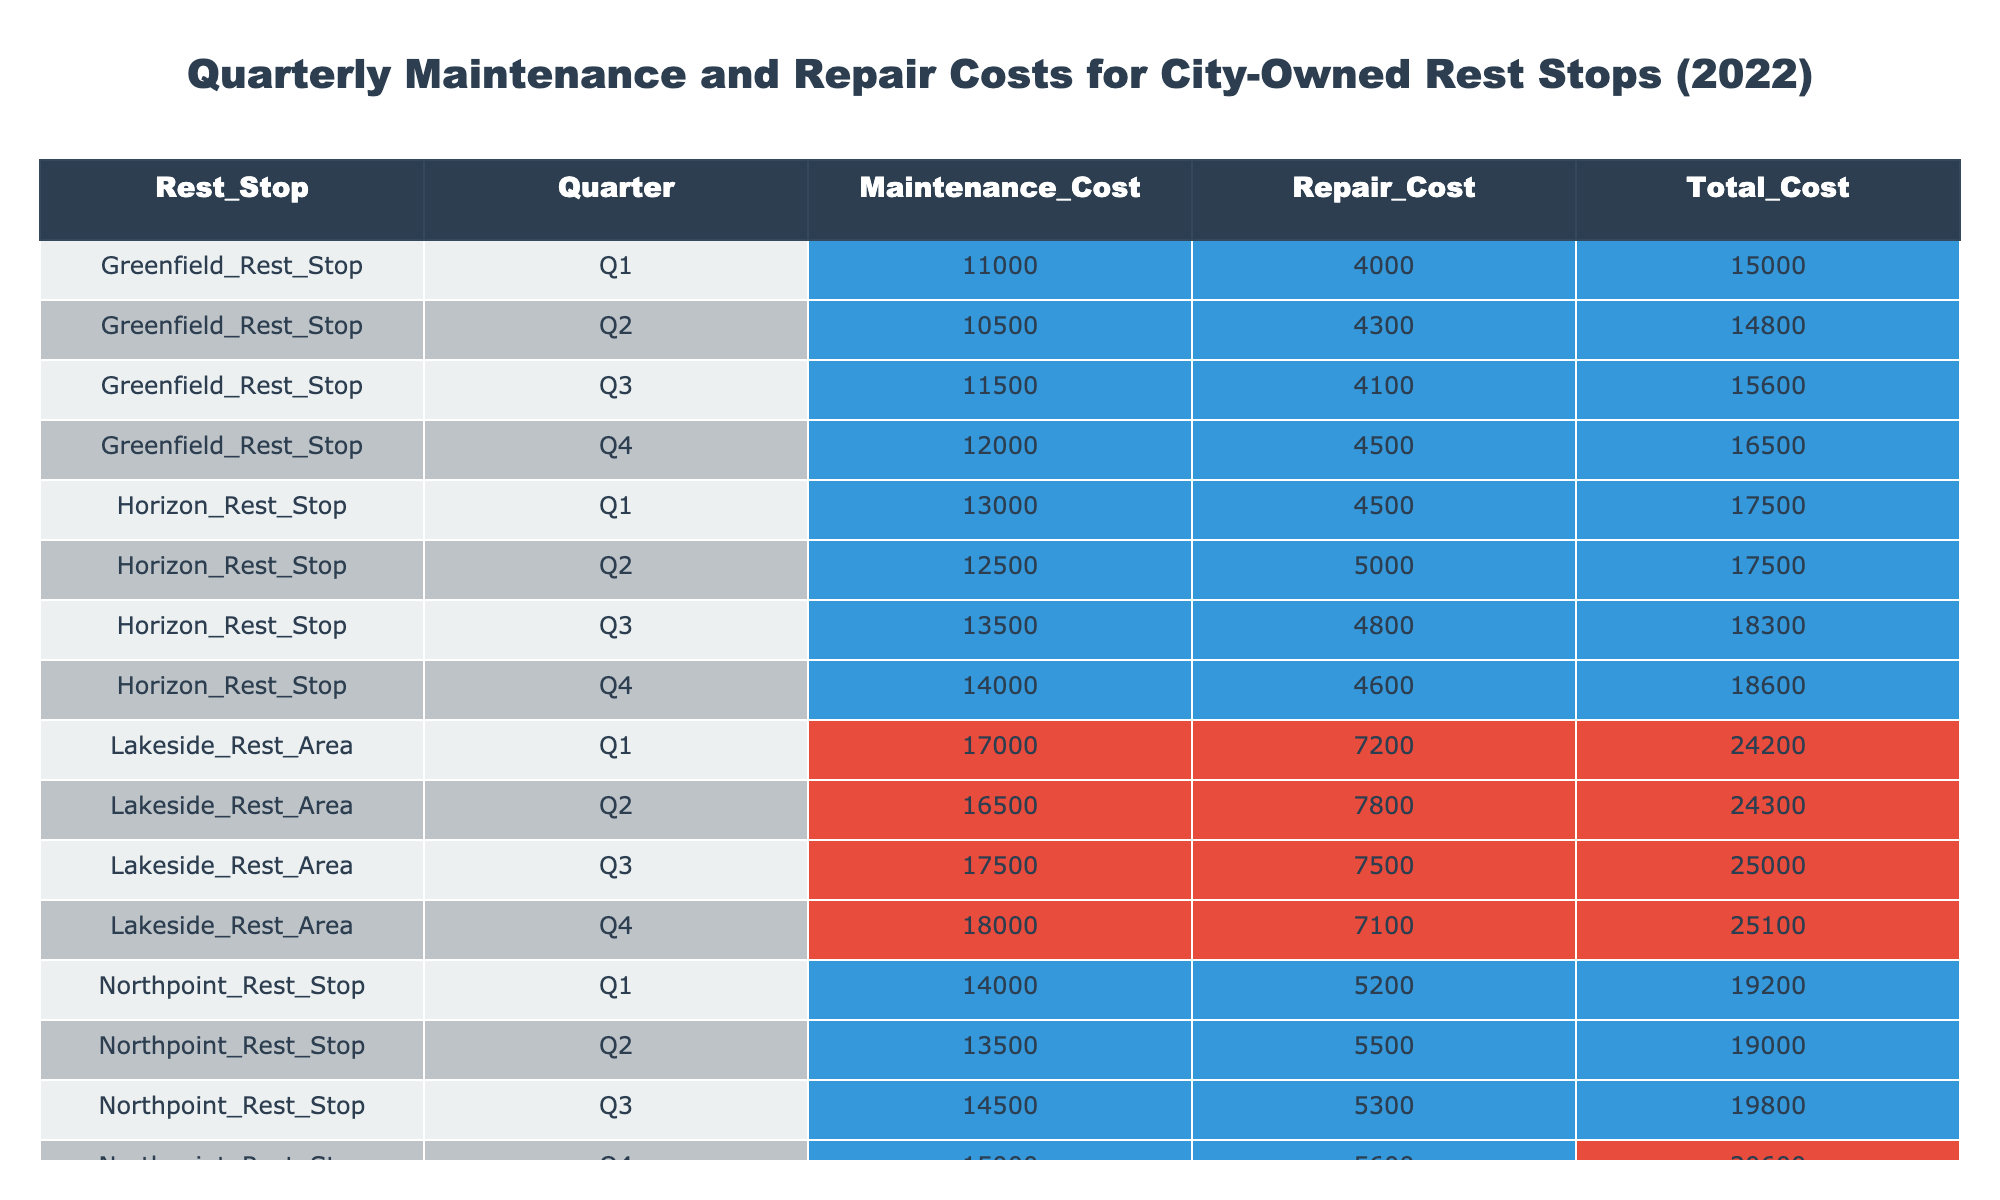What is the total maintenance cost for Sunset Rest Stop in Q3? From the table, for Sunset Rest Stop in Q3, the maintenance cost is listed as 16000.
Answer: 16000 Which rest stop had the highest total costs in Q2? Reviewing the table, Lakeside Rest Area has the highest total cost in Q2, which is 24300.
Answer: Lakeside Rest Area What is the average repair cost for Northpoint Rest Stop across all four quarters? The repair costs for Northpoint Rest Stop are 5200, 5500, 5300, and 5600. Adding these gives 5200 + 5500 + 5300 + 5600 = 21600. Dividing by 4 gives an average of 21600 / 4 = 5400.
Answer: 5400 Did Greenfield Rest Stop incur any repair costs over 4000 in Q1? According to the table, the repair cost for Greenfield Rest Stop in Q1 is 4000, which is not over 4000. Therefore, the answer is no.
Answer: No What is the total maintenance cost across all quarters for Horizon Rest Stop? For Horizon Rest Stop, the maintenance costs are 13000 (Q1), 12500 (Q2), 13500 (Q3), and 14000 (Q4). Summing these yields 13000 + 12500 + 13500 + 14000 = 53000.
Answer: 53000 Which quarter had the lowest total costs among all rest stops combined? To find the lowest total costs among all quarters, we sum the total costs for each stop per quarter. The totals are: Q1 = 20000 + 17500 + 24200 + 15000 + 19200 = 95900, Q2 = 20000 + 17500 + 24300 + 14800 + 19000 = 95600, Q3 = 21500 + 18300 + 25000 + 15600 + 19800 = 100600, and Q4 = 21200 + 18600 + 25100 + 16500 + 20600 = 102100. Thus, Q2 has the lowest total at 95600.
Answer: Q2 What is the difference in total costs between Lakeside Rest Area in Q4 and Greenfield Rest Stop in Q4? From the table, Lakeside Rest Area in Q4 has a total cost of 25100, while Greenfield Rest Stop in Q4 has a total cost of 16500. The difference is calculated as 25100 - 16500 = 8600.
Answer: 8600 Is the average maintenance cost for all rest stops in Q1 higher than 15000? Summing the maintenance costs for Q1: 15000 (Sunset) + 13000 (Horizon) + 17000 (Lakeside) + 11000 (Greenfield) + 14000 (Northpoint) gives 68000. Dividing this by 5 (the number of rest stops) results in an average of 13600, which is not higher than 15000.
Answer: No 